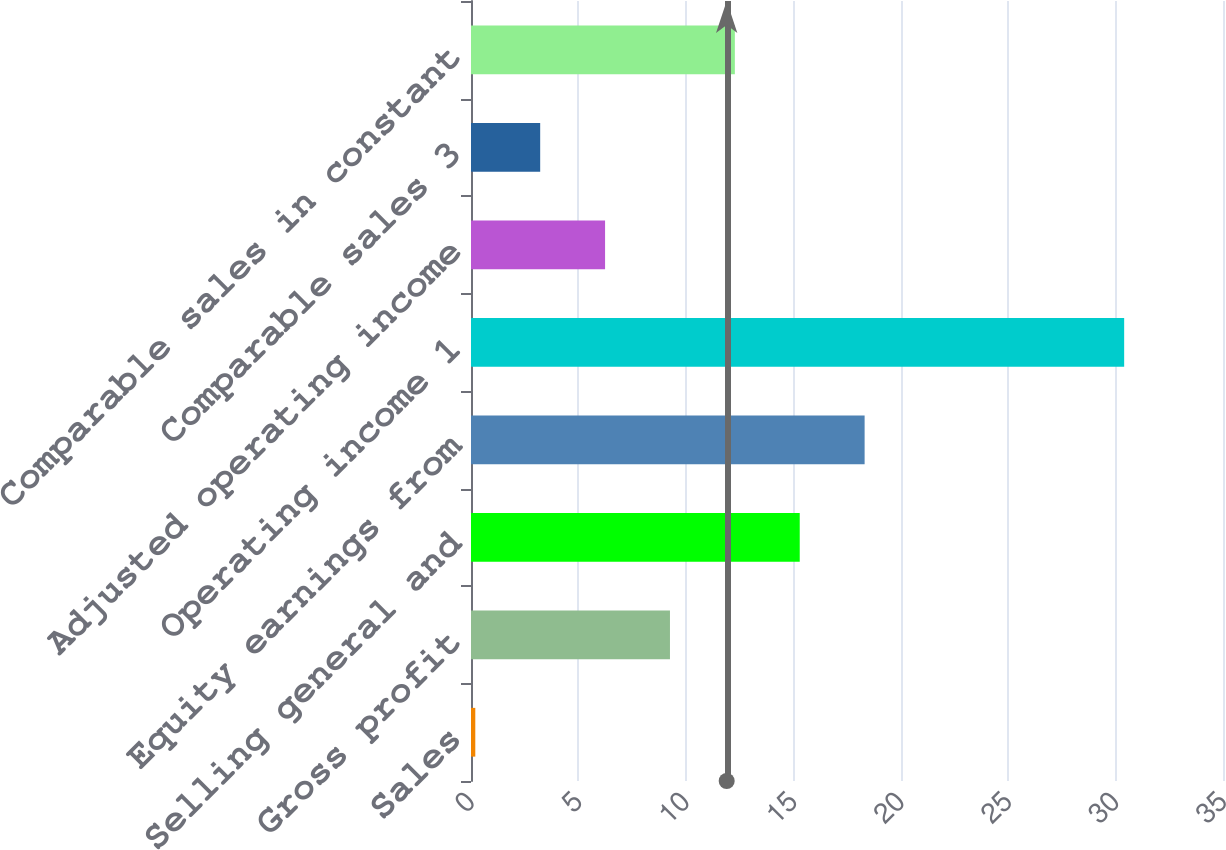Convert chart. <chart><loc_0><loc_0><loc_500><loc_500><bar_chart><fcel>Sales<fcel>Gross profit<fcel>Selling general and<fcel>Equity earnings from<fcel>Operating income 1<fcel>Adjusted operating income<fcel>Comparable sales 3<fcel>Comparable sales in constant<nl><fcel>0.2<fcel>9.26<fcel>15.3<fcel>18.32<fcel>30.4<fcel>6.24<fcel>3.22<fcel>12.28<nl></chart> 